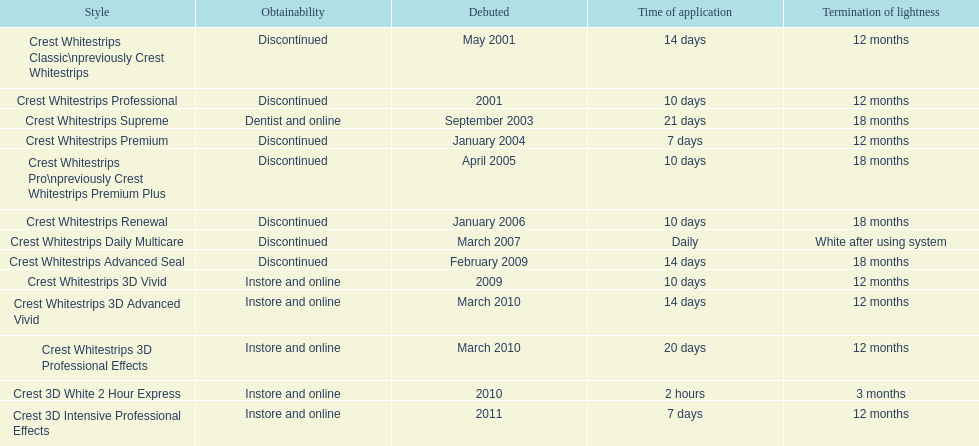Which model has the highest 'length of use' to 'last of whiteness' ratio? Crest Whitestrips Supreme. 